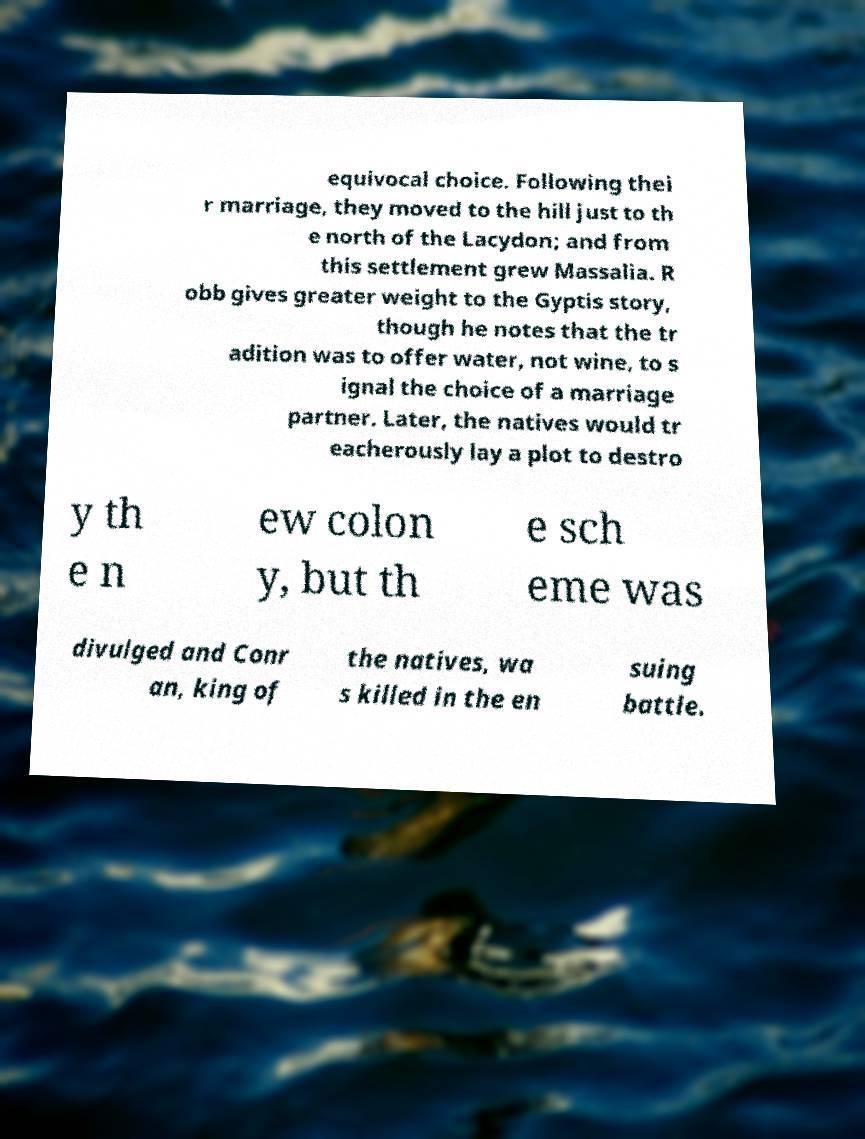For documentation purposes, I need the text within this image transcribed. Could you provide that? equivocal choice. Following thei r marriage, they moved to the hill just to th e north of the Lacydon; and from this settlement grew Massalia. R obb gives greater weight to the Gyptis story, though he notes that the tr adition was to offer water, not wine, to s ignal the choice of a marriage partner. Later, the natives would tr eacherously lay a plot to destro y th e n ew colon y, but th e sch eme was divulged and Conr an, king of the natives, wa s killed in the en suing battle. 